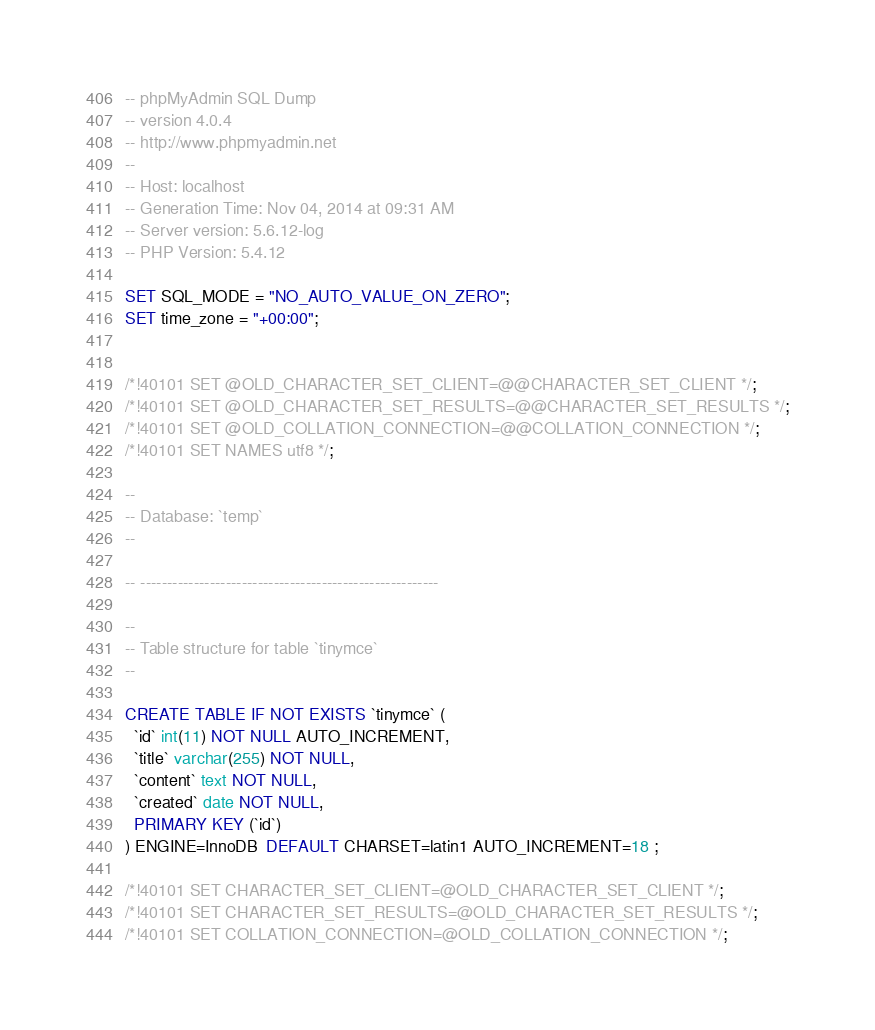Convert code to text. <code><loc_0><loc_0><loc_500><loc_500><_SQL_>-- phpMyAdmin SQL Dump
-- version 4.0.4
-- http://www.phpmyadmin.net
--
-- Host: localhost
-- Generation Time: Nov 04, 2014 at 09:31 AM
-- Server version: 5.6.12-log
-- PHP Version: 5.4.12

SET SQL_MODE = "NO_AUTO_VALUE_ON_ZERO";
SET time_zone = "+00:00";


/*!40101 SET @OLD_CHARACTER_SET_CLIENT=@@CHARACTER_SET_CLIENT */;
/*!40101 SET @OLD_CHARACTER_SET_RESULTS=@@CHARACTER_SET_RESULTS */;
/*!40101 SET @OLD_COLLATION_CONNECTION=@@COLLATION_CONNECTION */;
/*!40101 SET NAMES utf8 */;

--
-- Database: `temp`
--

-- --------------------------------------------------------

--
-- Table structure for table `tinymce`
--

CREATE TABLE IF NOT EXISTS `tinymce` (
  `id` int(11) NOT NULL AUTO_INCREMENT,
  `title` varchar(255) NOT NULL,
  `content` text NOT NULL,
  `created` date NOT NULL,
  PRIMARY KEY (`id`)
) ENGINE=InnoDB  DEFAULT CHARSET=latin1 AUTO_INCREMENT=18 ;

/*!40101 SET CHARACTER_SET_CLIENT=@OLD_CHARACTER_SET_CLIENT */;
/*!40101 SET CHARACTER_SET_RESULTS=@OLD_CHARACTER_SET_RESULTS */;
/*!40101 SET COLLATION_CONNECTION=@OLD_COLLATION_CONNECTION */;
</code> 